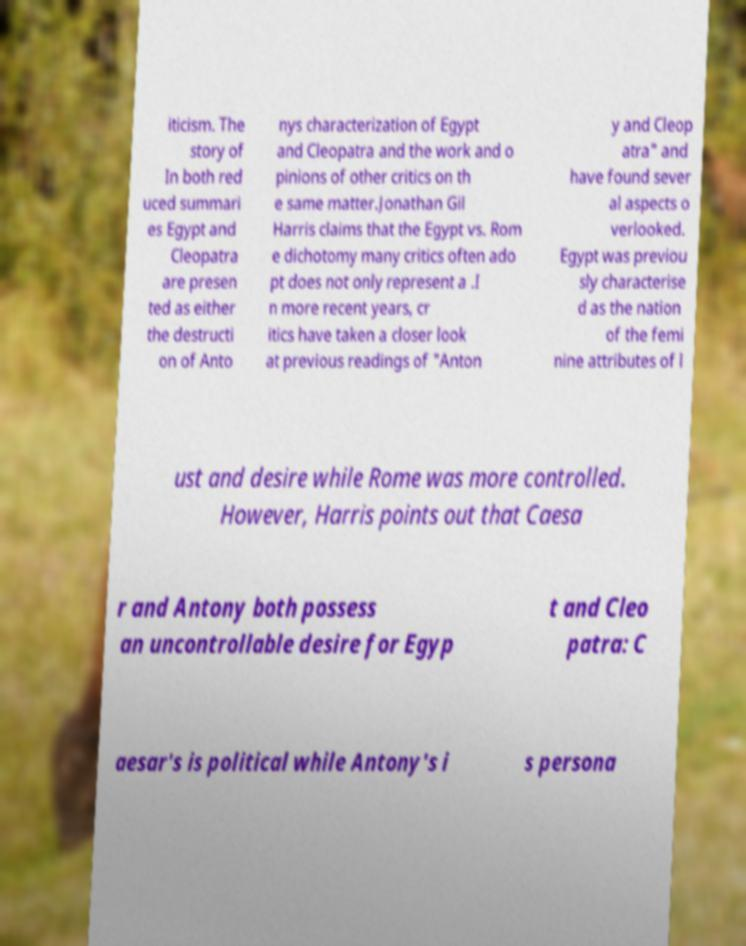There's text embedded in this image that I need extracted. Can you transcribe it verbatim? iticism. The story of In both red uced summari es Egypt and Cleopatra are presen ted as either the destructi on of Anto nys characterization of Egypt and Cleopatra and the work and o pinions of other critics on th e same matter.Jonathan Gil Harris claims that the Egypt vs. Rom e dichotomy many critics often ado pt does not only represent a .I n more recent years, cr itics have taken a closer look at previous readings of "Anton y and Cleop atra" and have found sever al aspects o verlooked. Egypt was previou sly characterise d as the nation of the femi nine attributes of l ust and desire while Rome was more controlled. However, Harris points out that Caesa r and Antony both possess an uncontrollable desire for Egyp t and Cleo patra: C aesar's is political while Antony's i s persona 